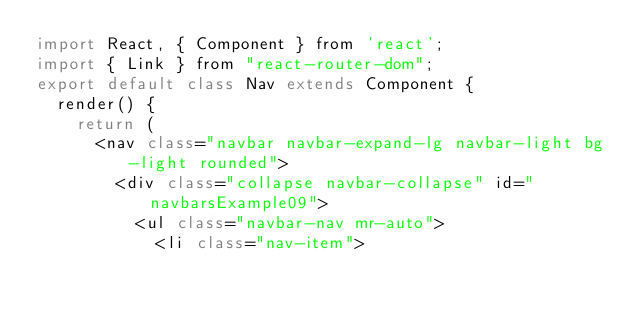<code> <loc_0><loc_0><loc_500><loc_500><_JavaScript_>import React, { Component } from 'react';
import { Link } from "react-router-dom";
export default class Nav extends Component {
  render() {
    return (
      <nav class="navbar navbar-expand-lg navbar-light bg-light rounded">
        <div class="collapse navbar-collapse" id="navbarsExample09">
          <ul class="navbar-nav mr-auto">
            <li class="nav-item"></code> 